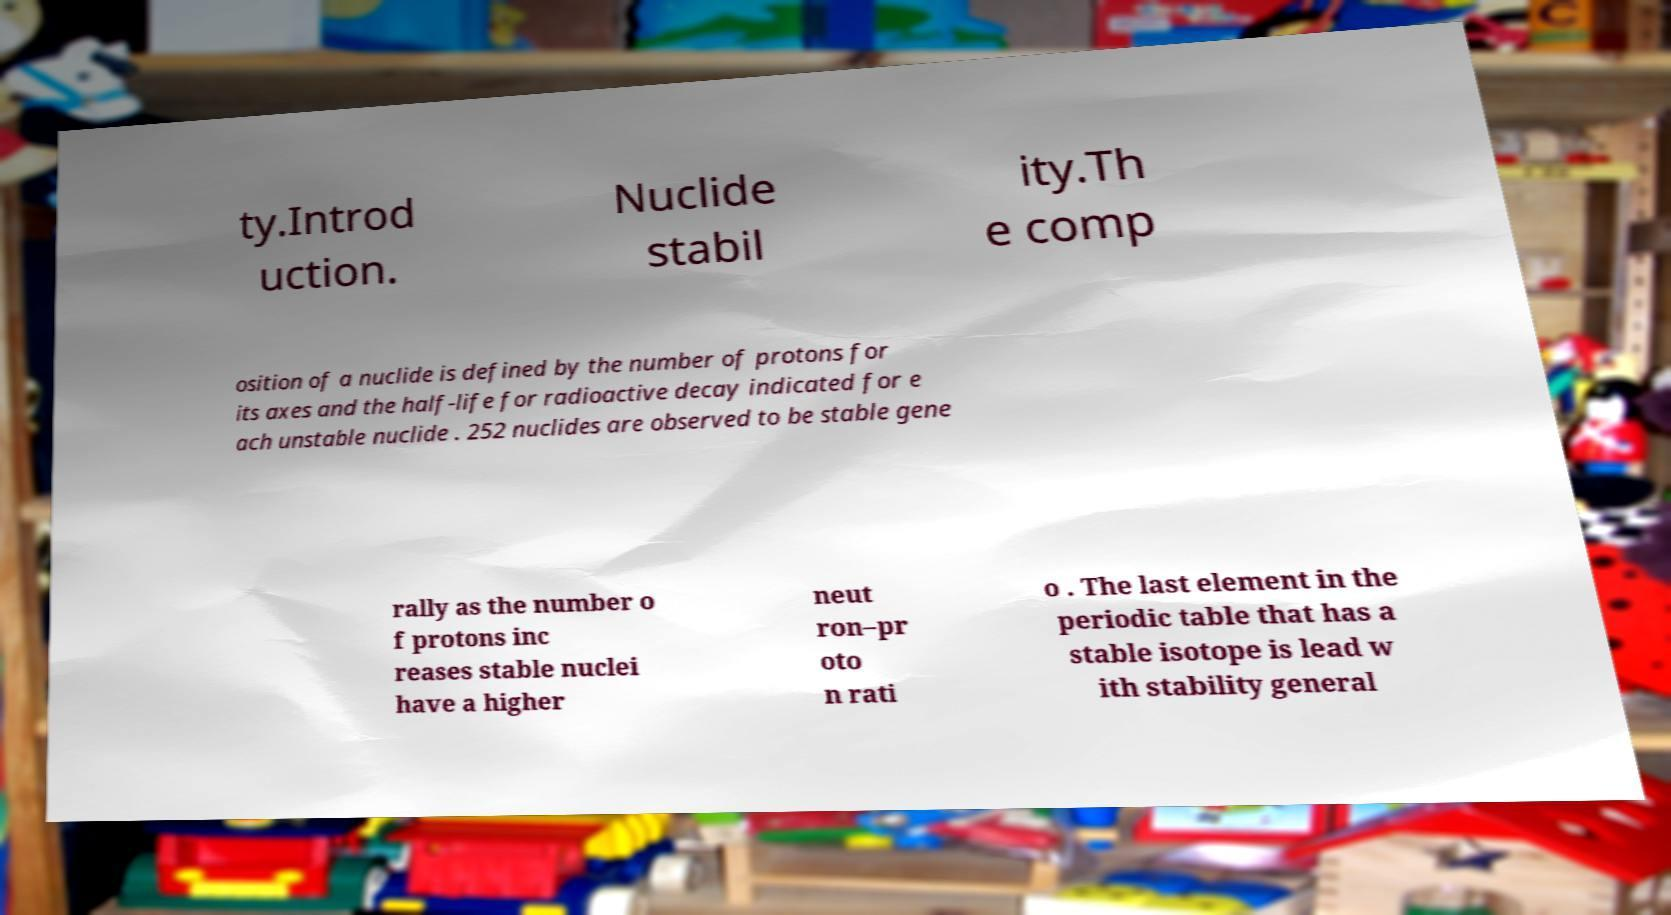I need the written content from this picture converted into text. Can you do that? ty.Introd uction. Nuclide stabil ity.Th e comp osition of a nuclide is defined by the number of protons for its axes and the half-life for radioactive decay indicated for e ach unstable nuclide . 252 nuclides are observed to be stable gene rally as the number o f protons inc reases stable nuclei have a higher neut ron–pr oto n rati o . The last element in the periodic table that has a stable isotope is lead w ith stability general 